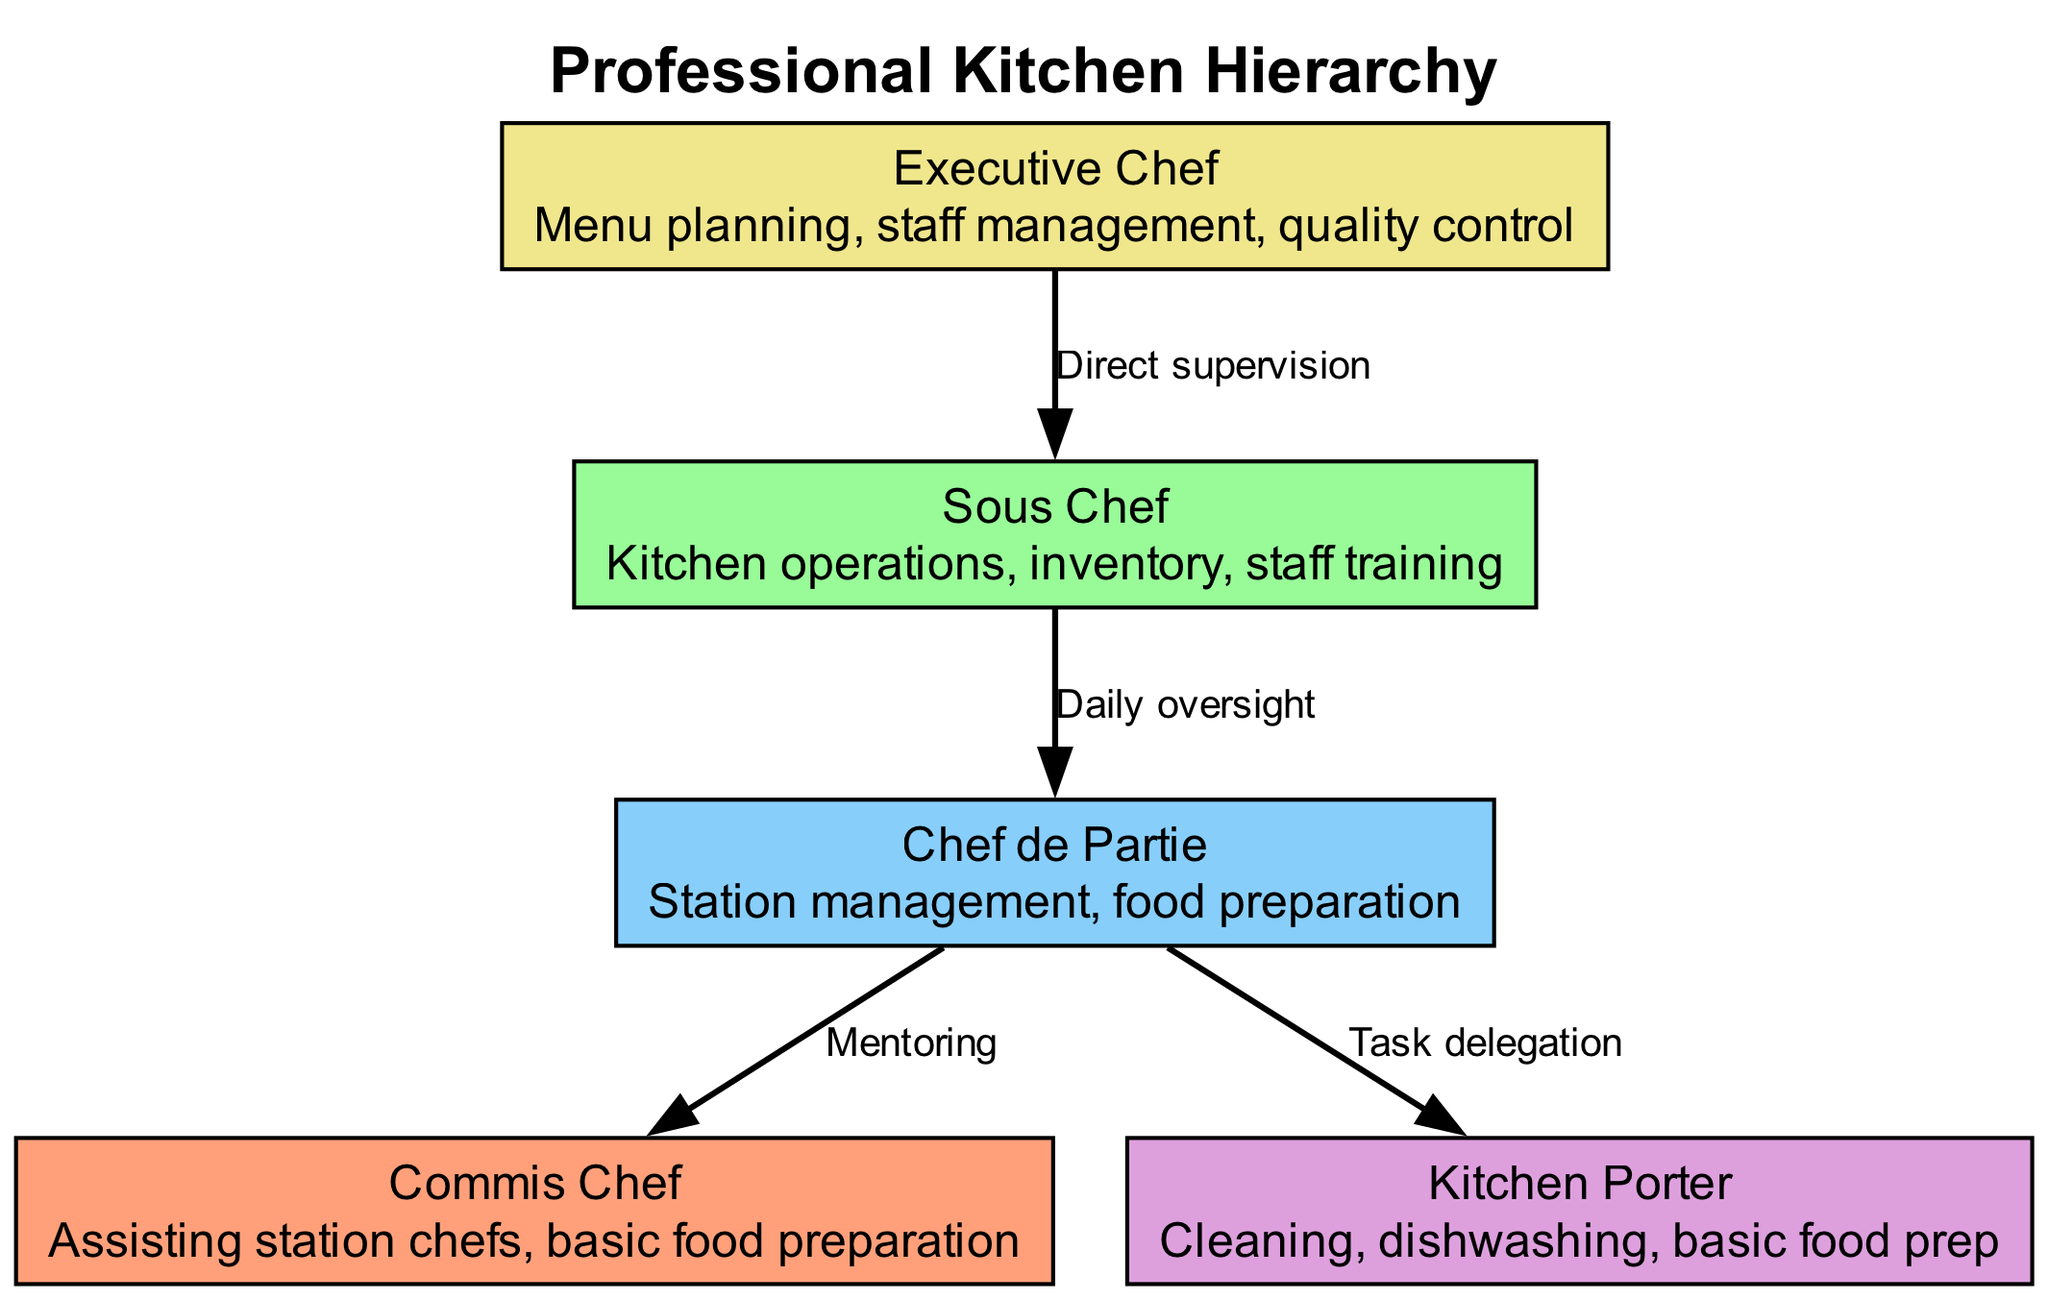What is the top role in the kitchen hierarchy? The diagram indicates that the top role is the Executive Chef, as it is positioned at the top of the hierarchy.
Answer: Executive Chef How many roles are present in the kitchen hierarchy? By counting the nodes from top to bottom, there are five distinct roles represented in the diagram.
Answer: Five Which role manages kitchen operations? The Sous Chef is responsible for managing kitchen operations as illustrated in the diagram.
Answer: Sous Chef What is the primary responsibility of a Kitchen Porter? The responsibilities of the Kitchen Porter include cleaning, dishwashing, and basic food preparation according to the diagram.
Answer: Cleaning, dishwashing, basic food prep Who does the Chef de Partie mentor? The Chef de Partie mentors the Commis Chef, as indicated by the directed edge labeled "Mentoring" from the Chef de Partie to the Commis Chef.
Answer: Commis Chef How does the Executive Chef communicate with the Sous Chef? The Executive Chef communicates with the Sous Chef through direct supervision, which is displayed as a directed edge labeled "Direct supervision" in the diagram.
Answer: Direct supervision Which position has the most responsibility for staff training? The Sous Chef holds the most responsibility for staff training in the professional kitchen hierarchy as highlighted in its listed responsibilities.
Answer: Sous Chef What role is responsible for task delegation? The Chef de Partie is responsible for task delegation to the Kitchen Porter, as noted by the arrow labeled "Task delegation" leading to the Kitchen Porter.
Answer: Chef de Partie How many communication channels are shown in the diagram? There are four communication channels represented as directed edges between different roles in the kitchen hierarchy.
Answer: Four 